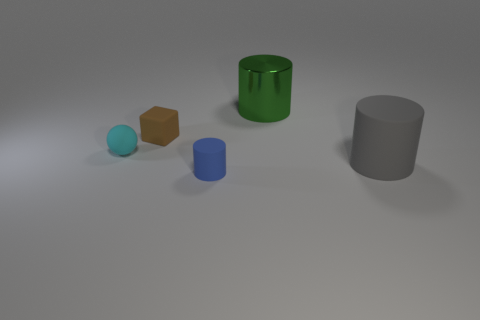Is there anything else that is the same material as the large green object?
Ensure brevity in your answer.  No. How many other objects are the same material as the blue object?
Provide a succinct answer. 3. There is a object that is the same size as the gray matte cylinder; what material is it?
Your response must be concise. Metal. There is a cylinder left of the big green object; is its color the same as the big cylinder that is behind the gray cylinder?
Make the answer very short. No. Is there another thing of the same shape as the large green metal object?
Give a very brief answer. Yes. The green thing that is the same size as the gray rubber cylinder is what shape?
Provide a succinct answer. Cylinder. How many matte cylinders are the same color as the big shiny cylinder?
Provide a succinct answer. 0. There is a rubber cylinder on the right side of the large metal object; how big is it?
Your response must be concise. Large. How many other things are the same size as the blue object?
Your answer should be compact. 2. The tiny ball that is the same material as the blue thing is what color?
Keep it short and to the point. Cyan. 